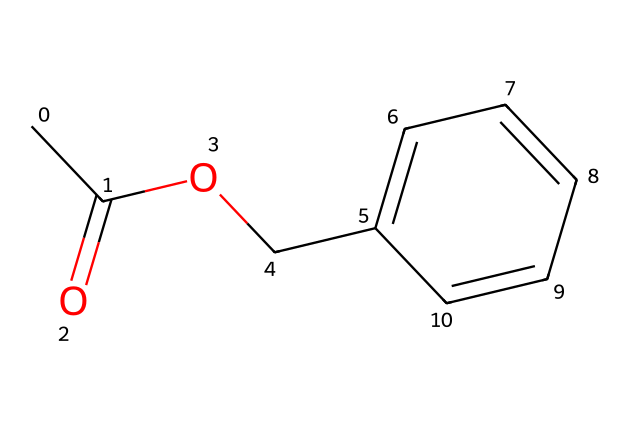What is the molecular formula of benzyl acetate? The molecular formula can be derived from the structure by counting the number of carbon, hydrogen, and oxygen atoms present. In benzyl acetate, there are 9 carbon atoms, 10 hydrogen atoms, and 2 oxygen atoms. Therefore, the molecular formula is C9H10O2.
Answer: C9H10O2 How many rings are present in the structure? The structure does not contain any rings; it is a linear structure with a phenyl group attached to an acetate function without any cyclic components. Therefore, the answer is zero.
Answer: zero What type of functional group is present in benzyl acetate? The chemical structure shows an ester group (RCOOR'), which is indicated by the presence of a carbonyl (C=O) and an oxygen atom bonded to another carbon. This indicates that benzyl acetate is classified as an ester.
Answer: ester What property allows benzyl acetate to smell like apples? The aroma of benzyl acetate is due to its specific molecular structure and functional groups that are characteristic of apple fragrances. The presence of the acetate functional group contributes to the fruity smell, making it an appealing flavor.
Answer: fruity smell Does benzyl acetate have any potential safety concerns for pets? Although benzyl acetate is considered safe for use in many pet-friendly products, excessive exposure could lead to irritation or allergic reactions in some pets, particularly those with sensitivities. Therefore, it is advised to ensure proper ventilation when used.
Answer: yes What is the primary application of benzyl acetate? This compound is primarily used as a flavoring agent and fragrance in air fresheners and other scented products, making it popular in the creation of pleasant environments, especially those designed to be pet-friendly.
Answer: air fresheners 